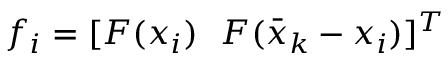<formula> <loc_0><loc_0><loc_500><loc_500>f _ { i } = [ F ( x _ { i } ) \ \ F ( \bar { x } _ { k } - x _ { i } ) ] ^ { T }</formula> 